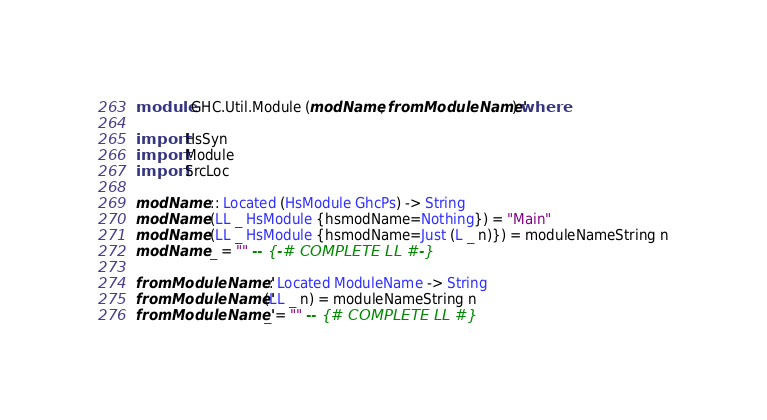<code> <loc_0><loc_0><loc_500><loc_500><_Haskell_>module GHC.Util.Module (modName, fromModuleName') where

import HsSyn
import Module
import SrcLoc

modName :: Located (HsModule GhcPs) -> String
modName (LL _ HsModule {hsmodName=Nothing}) = "Main"
modName (LL _ HsModule {hsmodName=Just (L _ n)}) = moduleNameString n
modName _ = "" -- {-# COMPLETE LL #-}

fromModuleName' :: Located ModuleName -> String
fromModuleName' (LL _ n) = moduleNameString n
fromModuleName' _ = "" -- {# COMPLETE LL #}
</code> 